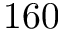<formula> <loc_0><loc_0><loc_500><loc_500>1 6 0</formula> 